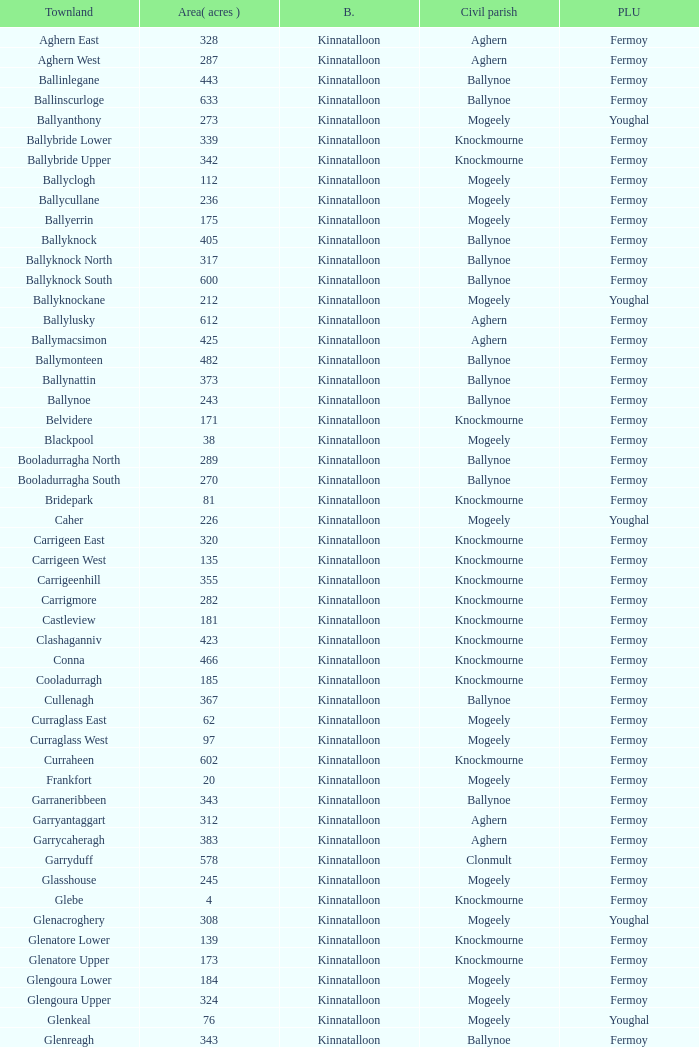Name the civil parish for garryduff Clonmult. 